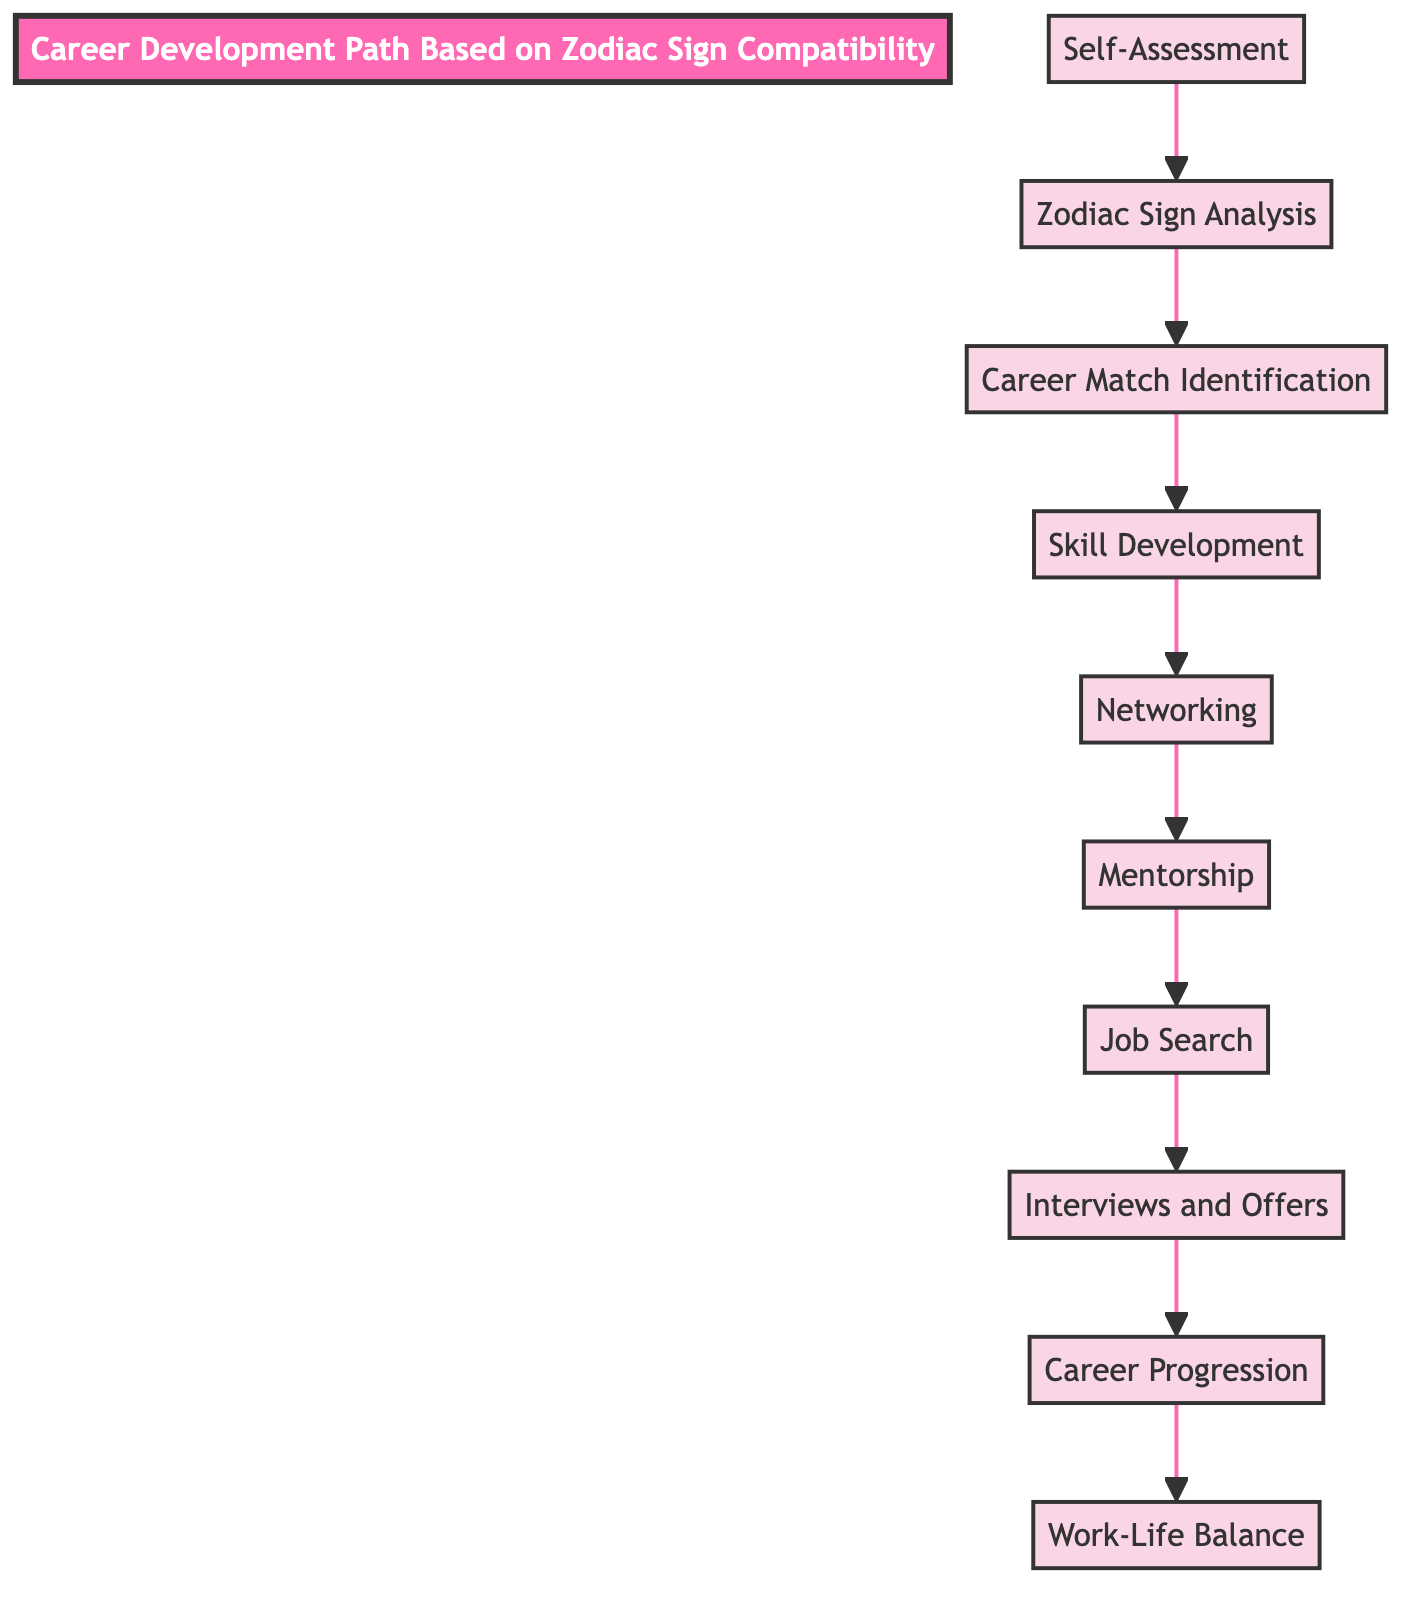What is the highest node in the diagram? The highest node in the diagram is "Work-Life Balance," which is positioned at the top of the flowchart. It is the final goal in the career development path.
Answer: Work-Life Balance How many elements are in the diagram? There are ten elements in the diagram, as each level represents a different stage in the career development path.
Answer: 10 What is the node directly above "Job Search"? The node directly above "Job Search" is "Mentorship," which indicates that mentorship is considered before the job search process.
Answer: Mentorship What is the relationship between "Self-Assessment" and "Career Match Identification"? "Self-Assessment" is the initial step that feeds into "Zodiac Sign Analysis," which then leads to "Career Match Identification," creating a sequential flow.
Answer: Sequential Which node is connected to "Skill Development"? "Skill Development" is directly connected to "Career Match Identification," indicating that after identifying a career match, one should develop relevant skills.
Answer: Career Match Identification What is the final step in the career development path? The final step in the career development path is "Work-Life Balance," which emphasizes the importance of maintaining a healthy balance between work and personal life.
Answer: Work-Life Balance Which step comes before "Interviews and Offers"? The step that comes before "Interviews and Offers" is "Job Search," suggesting that job applications must be completed before preparing for interviews.
Answer: Job Search What two nodes are connected to "Networking"? "Skill Development" leads to "Networking," which suggests that after developing skills, building connections is essential for progressing in the selected career. The preceding step to networking is "Skill Development."
Answer: Skill Development and Mentorship Which node indicates the importance of guidance from someone experienced? "Mentorship" indicates the importance of guidance from someone experienced, as it specifically mentions seeking guidance from mentors.
Answer: Mentorship 